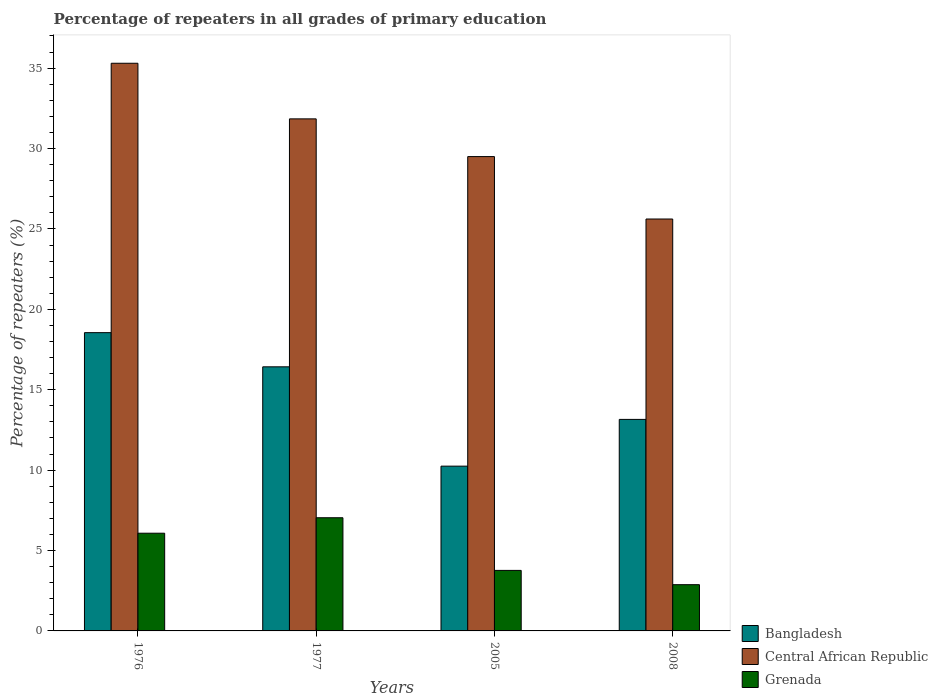How many different coloured bars are there?
Ensure brevity in your answer.  3. Are the number of bars on each tick of the X-axis equal?
Your answer should be very brief. Yes. How many bars are there on the 4th tick from the right?
Your answer should be compact. 3. What is the label of the 1st group of bars from the left?
Provide a succinct answer. 1976. In how many cases, is the number of bars for a given year not equal to the number of legend labels?
Provide a short and direct response. 0. What is the percentage of repeaters in Central African Republic in 2008?
Your answer should be very brief. 25.62. Across all years, what is the maximum percentage of repeaters in Grenada?
Provide a short and direct response. 7.04. Across all years, what is the minimum percentage of repeaters in Grenada?
Offer a very short reply. 2.88. In which year was the percentage of repeaters in Bangladesh maximum?
Provide a short and direct response. 1976. In which year was the percentage of repeaters in Central African Republic minimum?
Make the answer very short. 2008. What is the total percentage of repeaters in Bangladesh in the graph?
Your response must be concise. 58.38. What is the difference between the percentage of repeaters in Grenada in 1976 and that in 1977?
Ensure brevity in your answer.  -0.96. What is the difference between the percentage of repeaters in Bangladesh in 2005 and the percentage of repeaters in Central African Republic in 1976?
Make the answer very short. -25.06. What is the average percentage of repeaters in Central African Republic per year?
Provide a short and direct response. 30.57. In the year 2005, what is the difference between the percentage of repeaters in Central African Republic and percentage of repeaters in Grenada?
Provide a short and direct response. 25.74. In how many years, is the percentage of repeaters in Grenada greater than 12 %?
Offer a very short reply. 0. What is the ratio of the percentage of repeaters in Bangladesh in 1976 to that in 2008?
Offer a very short reply. 1.41. What is the difference between the highest and the second highest percentage of repeaters in Grenada?
Offer a very short reply. 0.96. What is the difference between the highest and the lowest percentage of repeaters in Grenada?
Provide a short and direct response. 4.16. In how many years, is the percentage of repeaters in Central African Republic greater than the average percentage of repeaters in Central African Republic taken over all years?
Your answer should be very brief. 2. What does the 2nd bar from the left in 2008 represents?
Keep it short and to the point. Central African Republic. Is it the case that in every year, the sum of the percentage of repeaters in Grenada and percentage of repeaters in Bangladesh is greater than the percentage of repeaters in Central African Republic?
Provide a succinct answer. No. How many bars are there?
Provide a succinct answer. 12. Are all the bars in the graph horizontal?
Offer a terse response. No. How many years are there in the graph?
Offer a terse response. 4. Are the values on the major ticks of Y-axis written in scientific E-notation?
Keep it short and to the point. No. Where does the legend appear in the graph?
Ensure brevity in your answer.  Bottom right. What is the title of the graph?
Make the answer very short. Percentage of repeaters in all grades of primary education. Does "Turks and Caicos Islands" appear as one of the legend labels in the graph?
Make the answer very short. No. What is the label or title of the Y-axis?
Your response must be concise. Percentage of repeaters (%). What is the Percentage of repeaters (%) in Bangladesh in 1976?
Your answer should be very brief. 18.55. What is the Percentage of repeaters (%) of Central African Republic in 1976?
Offer a terse response. 35.3. What is the Percentage of repeaters (%) of Grenada in 1976?
Your answer should be compact. 6.08. What is the Percentage of repeaters (%) of Bangladesh in 1977?
Your answer should be very brief. 16.42. What is the Percentage of repeaters (%) of Central African Republic in 1977?
Your answer should be very brief. 31.84. What is the Percentage of repeaters (%) of Grenada in 1977?
Offer a terse response. 7.04. What is the Percentage of repeaters (%) of Bangladesh in 2005?
Make the answer very short. 10.25. What is the Percentage of repeaters (%) of Central African Republic in 2005?
Provide a succinct answer. 29.5. What is the Percentage of repeaters (%) of Grenada in 2005?
Your answer should be compact. 3.76. What is the Percentage of repeaters (%) of Bangladesh in 2008?
Offer a terse response. 13.15. What is the Percentage of repeaters (%) of Central African Republic in 2008?
Offer a terse response. 25.62. What is the Percentage of repeaters (%) in Grenada in 2008?
Provide a succinct answer. 2.88. Across all years, what is the maximum Percentage of repeaters (%) in Bangladesh?
Your response must be concise. 18.55. Across all years, what is the maximum Percentage of repeaters (%) in Central African Republic?
Provide a short and direct response. 35.3. Across all years, what is the maximum Percentage of repeaters (%) of Grenada?
Offer a terse response. 7.04. Across all years, what is the minimum Percentage of repeaters (%) in Bangladesh?
Your response must be concise. 10.25. Across all years, what is the minimum Percentage of repeaters (%) of Central African Republic?
Your response must be concise. 25.62. Across all years, what is the minimum Percentage of repeaters (%) of Grenada?
Your response must be concise. 2.88. What is the total Percentage of repeaters (%) of Bangladesh in the graph?
Give a very brief answer. 58.38. What is the total Percentage of repeaters (%) of Central African Republic in the graph?
Make the answer very short. 122.26. What is the total Percentage of repeaters (%) in Grenada in the graph?
Offer a very short reply. 19.76. What is the difference between the Percentage of repeaters (%) of Bangladesh in 1976 and that in 1977?
Your answer should be very brief. 2.12. What is the difference between the Percentage of repeaters (%) in Central African Republic in 1976 and that in 1977?
Provide a short and direct response. 3.46. What is the difference between the Percentage of repeaters (%) of Grenada in 1976 and that in 1977?
Provide a short and direct response. -0.96. What is the difference between the Percentage of repeaters (%) in Bangladesh in 1976 and that in 2005?
Provide a short and direct response. 8.3. What is the difference between the Percentage of repeaters (%) of Central African Republic in 1976 and that in 2005?
Provide a short and direct response. 5.8. What is the difference between the Percentage of repeaters (%) of Grenada in 1976 and that in 2005?
Provide a succinct answer. 2.31. What is the difference between the Percentage of repeaters (%) in Bangladesh in 1976 and that in 2008?
Provide a short and direct response. 5.39. What is the difference between the Percentage of repeaters (%) in Central African Republic in 1976 and that in 2008?
Offer a terse response. 9.69. What is the difference between the Percentage of repeaters (%) of Grenada in 1976 and that in 2008?
Provide a succinct answer. 3.2. What is the difference between the Percentage of repeaters (%) of Bangladesh in 1977 and that in 2005?
Provide a succinct answer. 6.18. What is the difference between the Percentage of repeaters (%) of Central African Republic in 1977 and that in 2005?
Offer a terse response. 2.35. What is the difference between the Percentage of repeaters (%) in Grenada in 1977 and that in 2005?
Provide a succinct answer. 3.28. What is the difference between the Percentage of repeaters (%) in Bangladesh in 1977 and that in 2008?
Your answer should be very brief. 3.27. What is the difference between the Percentage of repeaters (%) of Central African Republic in 1977 and that in 2008?
Ensure brevity in your answer.  6.23. What is the difference between the Percentage of repeaters (%) in Grenada in 1977 and that in 2008?
Ensure brevity in your answer.  4.16. What is the difference between the Percentage of repeaters (%) of Bangladesh in 2005 and that in 2008?
Provide a short and direct response. -2.91. What is the difference between the Percentage of repeaters (%) of Central African Republic in 2005 and that in 2008?
Provide a short and direct response. 3.88. What is the difference between the Percentage of repeaters (%) in Grenada in 2005 and that in 2008?
Provide a succinct answer. 0.89. What is the difference between the Percentage of repeaters (%) of Bangladesh in 1976 and the Percentage of repeaters (%) of Central African Republic in 1977?
Keep it short and to the point. -13.3. What is the difference between the Percentage of repeaters (%) of Bangladesh in 1976 and the Percentage of repeaters (%) of Grenada in 1977?
Offer a terse response. 11.51. What is the difference between the Percentage of repeaters (%) of Central African Republic in 1976 and the Percentage of repeaters (%) of Grenada in 1977?
Keep it short and to the point. 28.26. What is the difference between the Percentage of repeaters (%) of Bangladesh in 1976 and the Percentage of repeaters (%) of Central African Republic in 2005?
Offer a very short reply. -10.95. What is the difference between the Percentage of repeaters (%) in Bangladesh in 1976 and the Percentage of repeaters (%) in Grenada in 2005?
Keep it short and to the point. 14.79. What is the difference between the Percentage of repeaters (%) of Central African Republic in 1976 and the Percentage of repeaters (%) of Grenada in 2005?
Your response must be concise. 31.54. What is the difference between the Percentage of repeaters (%) of Bangladesh in 1976 and the Percentage of repeaters (%) of Central African Republic in 2008?
Make the answer very short. -7.07. What is the difference between the Percentage of repeaters (%) in Bangladesh in 1976 and the Percentage of repeaters (%) in Grenada in 2008?
Keep it short and to the point. 15.67. What is the difference between the Percentage of repeaters (%) of Central African Republic in 1976 and the Percentage of repeaters (%) of Grenada in 2008?
Give a very brief answer. 32.43. What is the difference between the Percentage of repeaters (%) in Bangladesh in 1977 and the Percentage of repeaters (%) in Central African Republic in 2005?
Make the answer very short. -13.07. What is the difference between the Percentage of repeaters (%) in Bangladesh in 1977 and the Percentage of repeaters (%) in Grenada in 2005?
Offer a terse response. 12.66. What is the difference between the Percentage of repeaters (%) in Central African Republic in 1977 and the Percentage of repeaters (%) in Grenada in 2005?
Provide a short and direct response. 28.08. What is the difference between the Percentage of repeaters (%) of Bangladesh in 1977 and the Percentage of repeaters (%) of Central African Republic in 2008?
Offer a very short reply. -9.19. What is the difference between the Percentage of repeaters (%) in Bangladesh in 1977 and the Percentage of repeaters (%) in Grenada in 2008?
Your answer should be very brief. 13.55. What is the difference between the Percentage of repeaters (%) of Central African Republic in 1977 and the Percentage of repeaters (%) of Grenada in 2008?
Make the answer very short. 28.97. What is the difference between the Percentage of repeaters (%) of Bangladesh in 2005 and the Percentage of repeaters (%) of Central African Republic in 2008?
Your response must be concise. -15.37. What is the difference between the Percentage of repeaters (%) in Bangladesh in 2005 and the Percentage of repeaters (%) in Grenada in 2008?
Make the answer very short. 7.37. What is the difference between the Percentage of repeaters (%) in Central African Republic in 2005 and the Percentage of repeaters (%) in Grenada in 2008?
Provide a short and direct response. 26.62. What is the average Percentage of repeaters (%) in Bangladesh per year?
Make the answer very short. 14.59. What is the average Percentage of repeaters (%) in Central African Republic per year?
Make the answer very short. 30.57. What is the average Percentage of repeaters (%) of Grenada per year?
Offer a very short reply. 4.94. In the year 1976, what is the difference between the Percentage of repeaters (%) of Bangladesh and Percentage of repeaters (%) of Central African Republic?
Provide a short and direct response. -16.75. In the year 1976, what is the difference between the Percentage of repeaters (%) in Bangladesh and Percentage of repeaters (%) in Grenada?
Provide a succinct answer. 12.47. In the year 1976, what is the difference between the Percentage of repeaters (%) in Central African Republic and Percentage of repeaters (%) in Grenada?
Your answer should be very brief. 29.23. In the year 1977, what is the difference between the Percentage of repeaters (%) in Bangladesh and Percentage of repeaters (%) in Central African Republic?
Your answer should be very brief. -15.42. In the year 1977, what is the difference between the Percentage of repeaters (%) in Bangladesh and Percentage of repeaters (%) in Grenada?
Keep it short and to the point. 9.39. In the year 1977, what is the difference between the Percentage of repeaters (%) in Central African Republic and Percentage of repeaters (%) in Grenada?
Your answer should be very brief. 24.81. In the year 2005, what is the difference between the Percentage of repeaters (%) of Bangladesh and Percentage of repeaters (%) of Central African Republic?
Your answer should be very brief. -19.25. In the year 2005, what is the difference between the Percentage of repeaters (%) of Bangladesh and Percentage of repeaters (%) of Grenada?
Provide a succinct answer. 6.48. In the year 2005, what is the difference between the Percentage of repeaters (%) in Central African Republic and Percentage of repeaters (%) in Grenada?
Offer a very short reply. 25.74. In the year 2008, what is the difference between the Percentage of repeaters (%) of Bangladesh and Percentage of repeaters (%) of Central African Republic?
Make the answer very short. -12.46. In the year 2008, what is the difference between the Percentage of repeaters (%) in Bangladesh and Percentage of repeaters (%) in Grenada?
Keep it short and to the point. 10.28. In the year 2008, what is the difference between the Percentage of repeaters (%) of Central African Republic and Percentage of repeaters (%) of Grenada?
Offer a terse response. 22.74. What is the ratio of the Percentage of repeaters (%) in Bangladesh in 1976 to that in 1977?
Your answer should be very brief. 1.13. What is the ratio of the Percentage of repeaters (%) of Central African Republic in 1976 to that in 1977?
Give a very brief answer. 1.11. What is the ratio of the Percentage of repeaters (%) in Grenada in 1976 to that in 1977?
Provide a succinct answer. 0.86. What is the ratio of the Percentage of repeaters (%) in Bangladesh in 1976 to that in 2005?
Your answer should be compact. 1.81. What is the ratio of the Percentage of repeaters (%) of Central African Republic in 1976 to that in 2005?
Provide a succinct answer. 1.2. What is the ratio of the Percentage of repeaters (%) of Grenada in 1976 to that in 2005?
Your response must be concise. 1.61. What is the ratio of the Percentage of repeaters (%) of Bangladesh in 1976 to that in 2008?
Make the answer very short. 1.41. What is the ratio of the Percentage of repeaters (%) of Central African Republic in 1976 to that in 2008?
Your answer should be compact. 1.38. What is the ratio of the Percentage of repeaters (%) of Grenada in 1976 to that in 2008?
Your answer should be compact. 2.11. What is the ratio of the Percentage of repeaters (%) of Bangladesh in 1977 to that in 2005?
Offer a terse response. 1.6. What is the ratio of the Percentage of repeaters (%) of Central African Republic in 1977 to that in 2005?
Ensure brevity in your answer.  1.08. What is the ratio of the Percentage of repeaters (%) of Grenada in 1977 to that in 2005?
Give a very brief answer. 1.87. What is the ratio of the Percentage of repeaters (%) of Bangladesh in 1977 to that in 2008?
Give a very brief answer. 1.25. What is the ratio of the Percentage of repeaters (%) in Central African Republic in 1977 to that in 2008?
Provide a succinct answer. 1.24. What is the ratio of the Percentage of repeaters (%) of Grenada in 1977 to that in 2008?
Make the answer very short. 2.45. What is the ratio of the Percentage of repeaters (%) in Bangladesh in 2005 to that in 2008?
Give a very brief answer. 0.78. What is the ratio of the Percentage of repeaters (%) of Central African Republic in 2005 to that in 2008?
Your response must be concise. 1.15. What is the ratio of the Percentage of repeaters (%) in Grenada in 2005 to that in 2008?
Offer a terse response. 1.31. What is the difference between the highest and the second highest Percentage of repeaters (%) of Bangladesh?
Offer a very short reply. 2.12. What is the difference between the highest and the second highest Percentage of repeaters (%) in Central African Republic?
Make the answer very short. 3.46. What is the difference between the highest and the second highest Percentage of repeaters (%) in Grenada?
Provide a succinct answer. 0.96. What is the difference between the highest and the lowest Percentage of repeaters (%) in Bangladesh?
Your answer should be very brief. 8.3. What is the difference between the highest and the lowest Percentage of repeaters (%) in Central African Republic?
Provide a succinct answer. 9.69. What is the difference between the highest and the lowest Percentage of repeaters (%) of Grenada?
Your response must be concise. 4.16. 